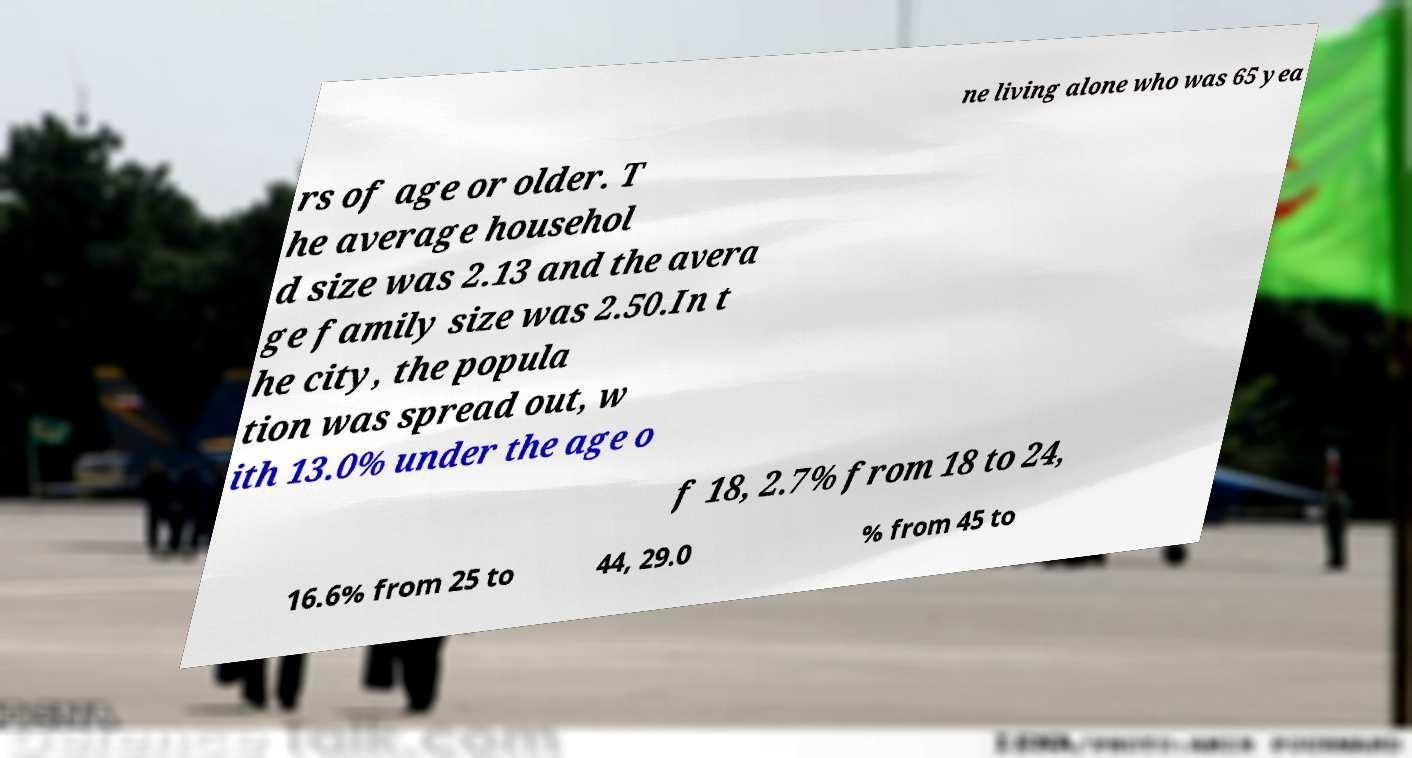Could you extract and type out the text from this image? ne living alone who was 65 yea rs of age or older. T he average househol d size was 2.13 and the avera ge family size was 2.50.In t he city, the popula tion was spread out, w ith 13.0% under the age o f 18, 2.7% from 18 to 24, 16.6% from 25 to 44, 29.0 % from 45 to 